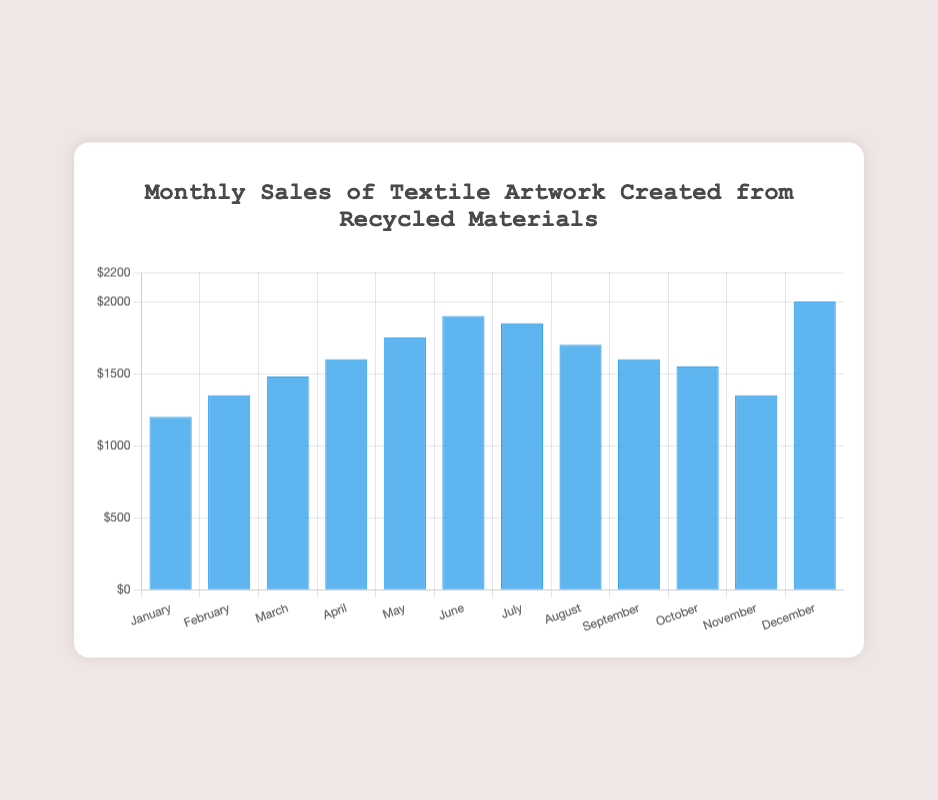What is the month with the highest sales? Looking at the data, December has the highest sales figure of $2000.
Answer: December What is the difference in sales between January and February? January sales are $1200 and February sales are $1350. The difference is $1350 - $1200 = $150.
Answer: $150 Which month had the lowest sales? By examining the data, January has the lowest sales figure of $1200.
Answer: January What are the total sales for the first quarter (January to March)? Sales for January, February, and March are $1200, $1350, and $1480 respectively. Summing these values: $1200 + $1350 + $1480 = $4030.
Answer: $4030 How many months had sales greater than $1500? Checking the data, the months with sales greater than $1500 are March ($1480 not counted), April ($1600), May ($1750), June ($1900), July ($1850), August ($1700), September ($1600), October ($1550), and December ($2000). There are 8 such months.
Answer: 8 What is the average sales for the entire year? Summing all sales for each month: $1200 + $1350 + $1480 + $1600 + $1750 + $1900 + $1850 + $1700 + $1600 + $1550 + $1350 + $2000 = $20230. Dividing by 12 (total number of months): $20230 / 12 ≈ $1685.83.
Answer: $1685.83 Compare the sales figure of July with that of June. Did the sales increase or decrease? July sales are $1850 while June sales are $1900. The sales decreased by $1900 - $1850 = $50.
Answer: Decreased What is the total sales for the second half of the year (July to December)? Sales for July, August, September, October, November, and December are $1850, $1700, $1600, $1550, $1350, and $2000 respectively. Summing these values: $1850 + $1700 + $1600 + $1550 + $1350 + $2000 = $10050.
Answer: $10050 Which month had the greatest increase in sales compared to the previous month? Calculating monthly differences: 
Jan to Feb: $1350 - $1200 = $150 
Feb to Mar: $1480 - $1350 = $130
Mar to Apr: $1600 - $1480 = $120
Apr to May: $1750 - $1600 = $150
May to Jun: $1900 - $1750 = $150
Jun to Jul: $1850 - $1900 = -$50
Jul to Aug: $1700 - $1850 = -$150
Aug to Sep: $1600 - $1700 = -$100
Sep to Oct: $1550 - $1600 = -$50
Oct to Nov: $1350 - $1550 = -$200
Nov to Dec: $2000 - $1350 = $650
The greatest increase is from November to December with $650.
Answer: November to December, $650 What's the difference between the highest and the lowest monthly sales figures? The highest sales figure is December with $2000, and the lowest is January with $1200. The difference is $2000 - $1200 = $800.
Answer: $800 